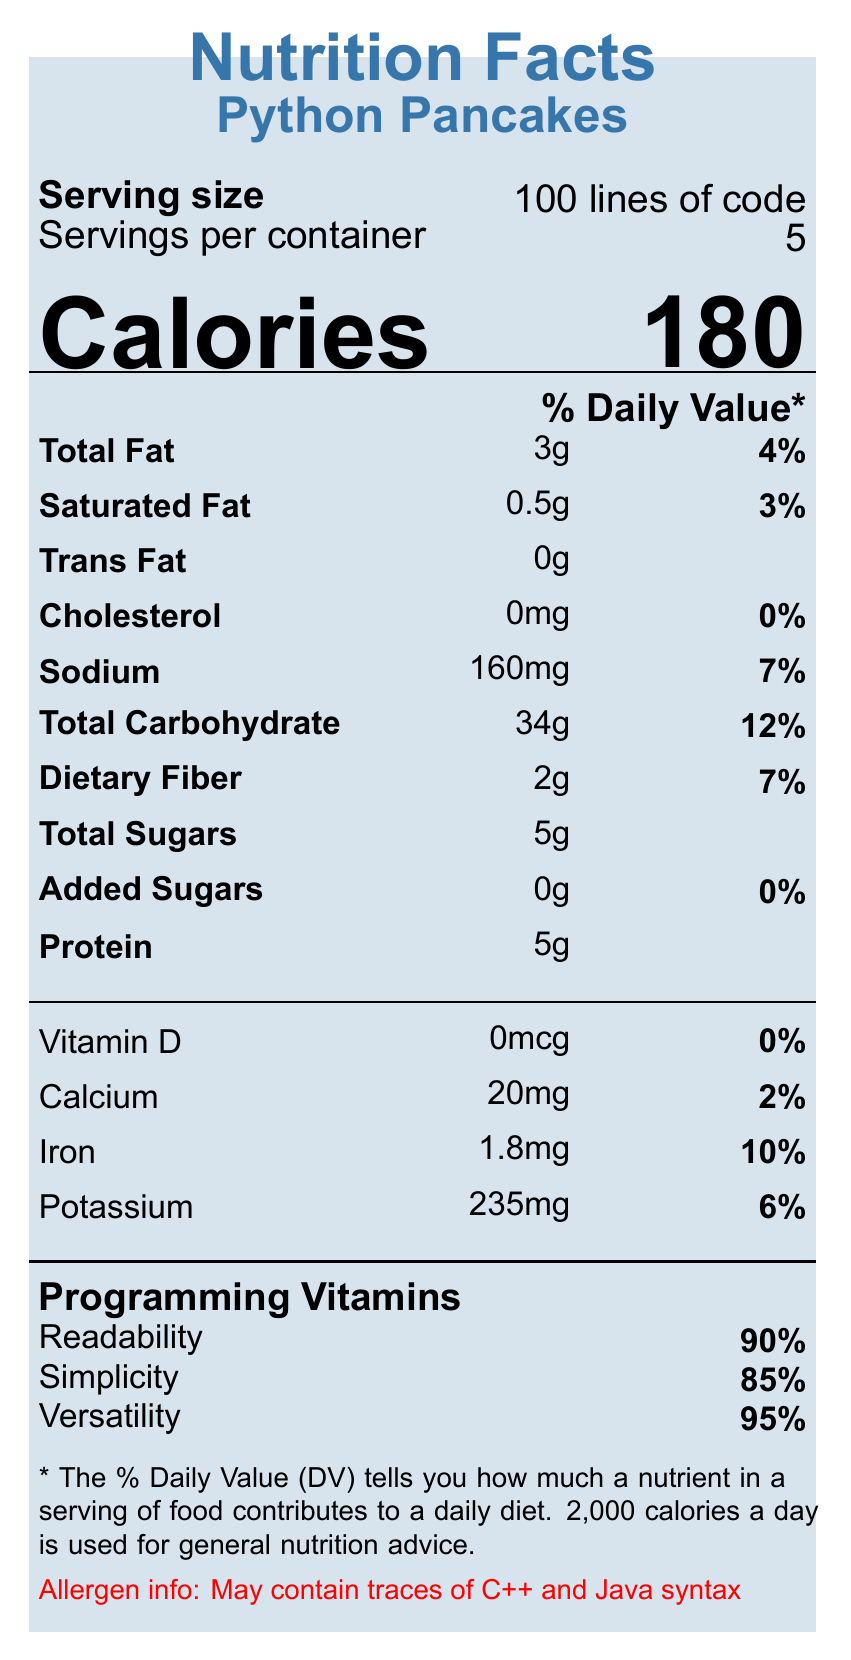what is the serving size of Python Pancakes? The document states that the serving size is "100 lines of code" under the serving information section.
Answer: 100 lines of code how many servings per container for Python Pancakes? The document specifies "5" as the servings per container in the serving information section.
Answer: 5 how many calories are in one serving of Python Pancakes? The calories section lists "180" calories per serving.
Answer: 180 what is the total fat content in one serving? The "Total Fat" entry under the nutrition information section indicates there are 3 grams of total fat per serving.
Answer: 3g what percentage of daily value does the dietary fiber contribute? The "Dietary Fiber" entry contributes 7% to the daily value as noted in the nutrition information section.
Answer: 7% to which nutrient does Python Pancakes contribute the highest daily value percentage? "Total Carbohydrate" contributes 12% to the daily value, which is the highest among all listed nutrients.
Answer: Total Carbohydrate how much sodium is in one serving of Python Pancakes? The document lists "Sodium" as having 160mg per serving.
Answer: 160mg what is the purpose of including "Programming Vitamins" in the document? The "Programming Vitamins" section lists attributes like Readability, Simplicity, and Versatility, indicating non-nutritional benefits.
Answer: To highlight non-nutritional benefits like readability, simplicity, and versatility in the context of programming languages. which of these is not an ingredient in Python Pancakes? A. Exception handling B. Lambda functions C. Templates D. File I/O Templates are not listed as one of the ingredients; however, Exception handling, Lambda functions, and File I/O are.
Answer: C. Templates which IDE listed is known for its built-in GUI designer? A. IDLE B. Visual Studio Code C. PyCharm D. Sublime Text PyCharm is mentioned as a popular IDE with an advanced GUI designer under the developer tools section.
Answer: C. PyCharm does Python Pancakes contain any added sugars? The "Added Sugars" entry indicates 0g and 0% daily value, meaning there are no added sugars.
Answer: No summarize the main nutritional and additional information provided for Python Pancakes. The document conveys a playful, informative breakdown of Python's attributes and historical context using the format of a nutrition facts label, blending nutritional facts with programming features.
Answer: Python Pancakes provides basic nutritional information similar to that of food labels but in the context of lines of code, including attributes like total fat, carbohydrates, and protein. It also highlights non-nutritional benefits such as readability, simplicity, and versatility in programming. Additionally, historical notes, GUI-related features, and developer tools are listed to provide a comprehensive view of Python as a programming language. who created Python and in what year? The visual document does not provide information on the creator of Python or the year it was created; that information is typically part of the historical notes not visible in the visual rendering.
Answer: Cannot be determined 